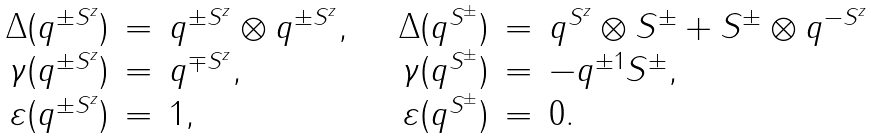Convert formula to latex. <formula><loc_0><loc_0><loc_500><loc_500>\begin{array} { r c l r c l } { { \Delta ( q ^ { \pm S ^ { z } } ) } } & { = } & { { q ^ { \pm S ^ { z } } \otimes q ^ { \pm S ^ { z } } , \quad } } & { { \Delta ( q ^ { S ^ { \pm } } ) } } & { = } & { { q ^ { S ^ { z } } \otimes S ^ { \pm } + S ^ { \pm } \otimes q ^ { - S ^ { z } } } } \\ { { { \gamma } ( q ^ { \pm S ^ { z } } ) } } & { = } & { { q ^ { \mp S ^ { z } } , } } & { { { \gamma } ( q ^ { S ^ { \pm } } ) } } & { = } & { { - q ^ { \pm 1 } S ^ { \pm } , } } \\ { { \varepsilon ( q ^ { \pm S ^ { z } } ) } } & { = } & { 1 , } & { { \varepsilon ( q ^ { S ^ { \pm } } ) } } & { = } & { 0 . } \end{array}</formula> 